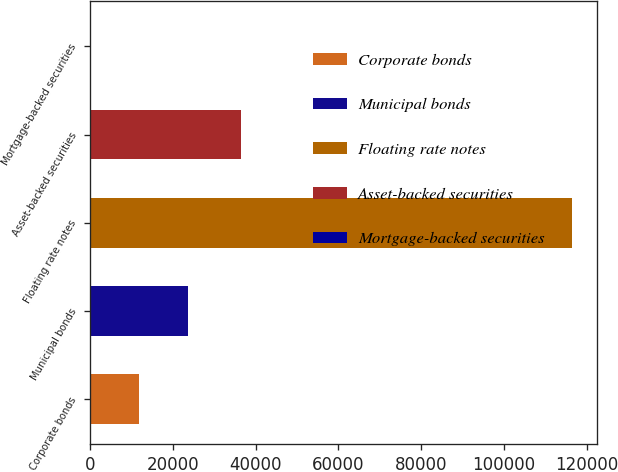Convert chart. <chart><loc_0><loc_0><loc_500><loc_500><bar_chart><fcel>Corporate bonds<fcel>Municipal bonds<fcel>Floating rate notes<fcel>Asset-backed securities<fcel>Mortgage-backed securities<nl><fcel>11934<fcel>23562<fcel>116586<fcel>36492<fcel>306<nl></chart> 